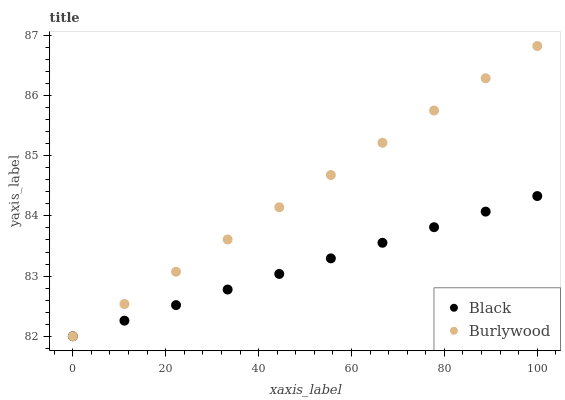Does Black have the minimum area under the curve?
Answer yes or no. Yes. Does Burlywood have the maximum area under the curve?
Answer yes or no. Yes. Does Black have the maximum area under the curve?
Answer yes or no. No. Is Burlywood the smoothest?
Answer yes or no. Yes. Is Black the roughest?
Answer yes or no. Yes. Is Black the smoothest?
Answer yes or no. No. Does Burlywood have the lowest value?
Answer yes or no. Yes. Does Burlywood have the highest value?
Answer yes or no. Yes. Does Black have the highest value?
Answer yes or no. No. Does Black intersect Burlywood?
Answer yes or no. Yes. Is Black less than Burlywood?
Answer yes or no. No. Is Black greater than Burlywood?
Answer yes or no. No. 